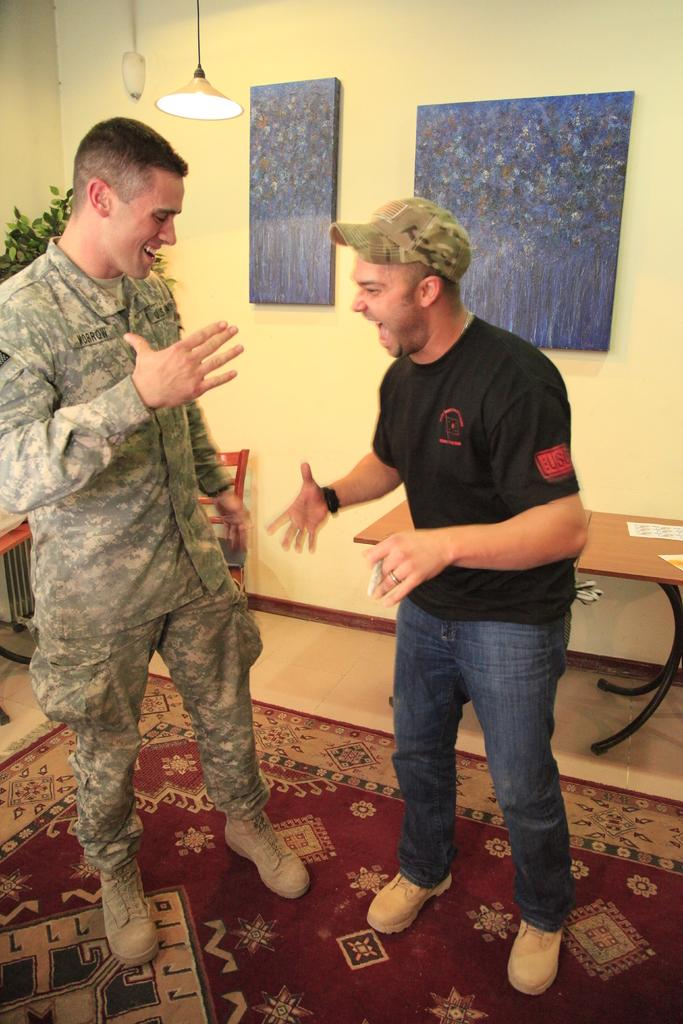How many people are in the image? There are two persons standing in the image. Where are the persons standing? The persons are standing on the floor. What can be seen in the background of the image? There are tables, chairs, posters, and lights in the background of the image. What is the color of the background in the image? The background color is yellow. Are there any beads used as decoration in the image? There is no mention of beads in the provided facts, so we cannot determine if they are present in the image. What type of war is depicted in the image? There is no depiction of war in the image; it features two persons standing on the floor with a yellow background and various background elements. 